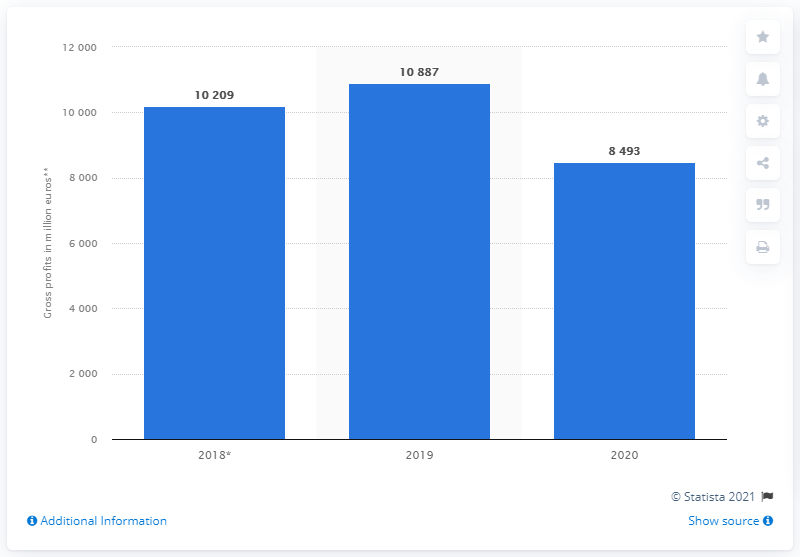Draw attention to some important aspects in this diagram. The global gross profit of EssilorLuxottica in 2020 was 8,493. The gross profit of EssilorLuxottica for the previous year was 10887. 